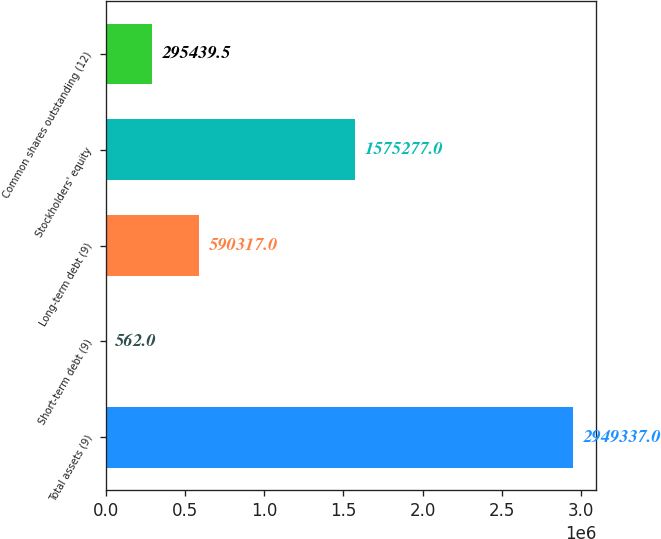Convert chart. <chart><loc_0><loc_0><loc_500><loc_500><bar_chart><fcel>Total assets (9)<fcel>Short-term debt (9)<fcel>Long-term debt (9)<fcel>Stockholders' equity<fcel>Common shares outstanding (12)<nl><fcel>2.94934e+06<fcel>562<fcel>590317<fcel>1.57528e+06<fcel>295440<nl></chart> 